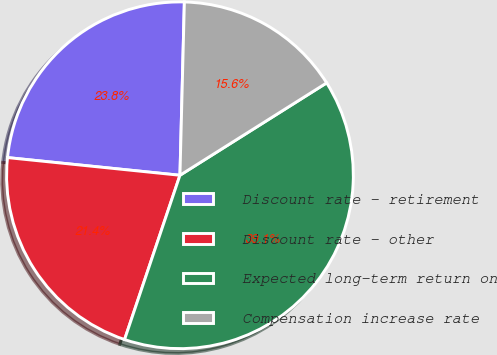Convert chart to OTSL. <chart><loc_0><loc_0><loc_500><loc_500><pie_chart><fcel>Discount rate - retirement<fcel>Discount rate - other<fcel>Expected long-term return on<fcel>Compensation increase rate<nl><fcel>23.78%<fcel>21.45%<fcel>39.12%<fcel>15.65%<nl></chart> 